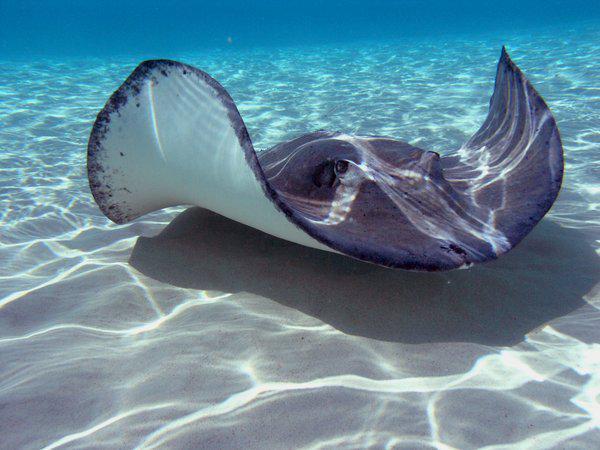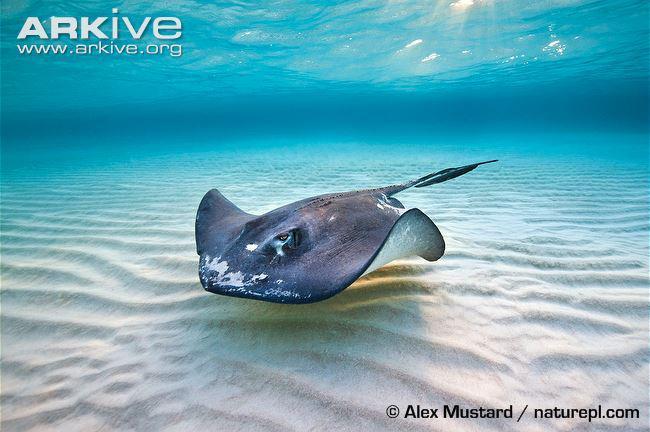The first image is the image on the left, the second image is the image on the right. For the images shown, is this caption "The left and right image contains the same stingrays hovering over the sand." true? Answer yes or no. Yes. 